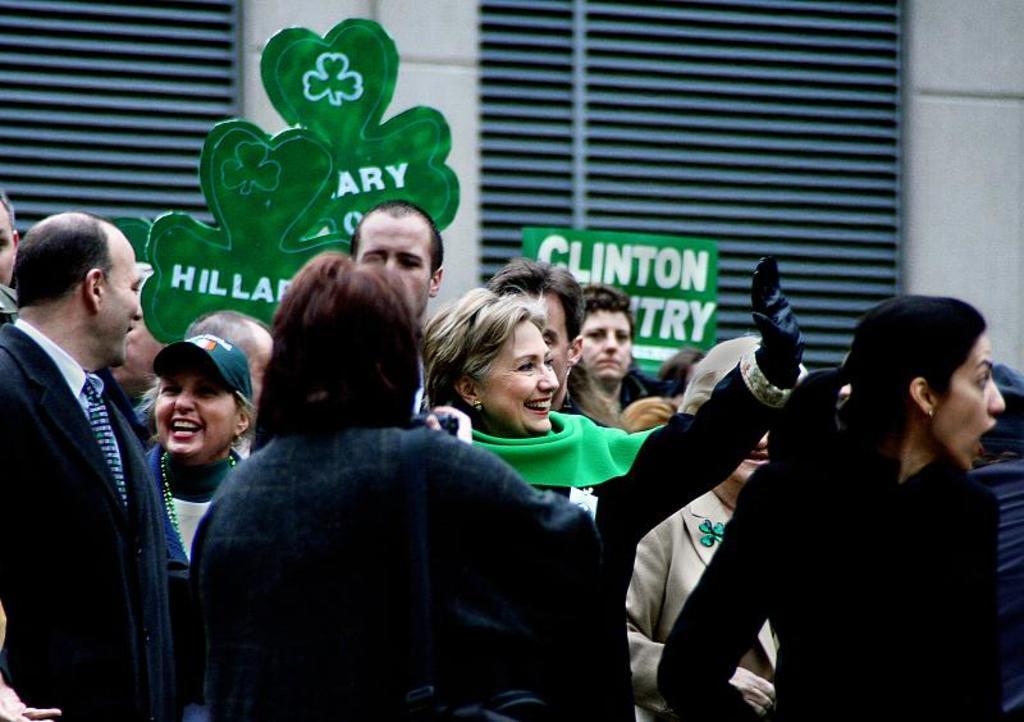Describe this image in one or two sentences. This picture describes about group of people, in the middle of the image we can see a woman, she is smiling, beside to her we can find another woman, she wore a cap, in the background we can see window blinds and a placard. 